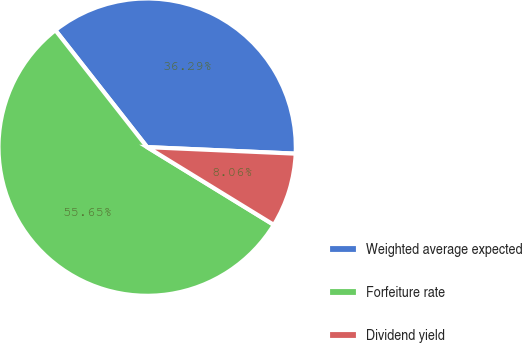Convert chart. <chart><loc_0><loc_0><loc_500><loc_500><pie_chart><fcel>Weighted average expected<fcel>Forfeiture rate<fcel>Dividend yield<nl><fcel>36.29%<fcel>55.65%<fcel>8.06%<nl></chart> 